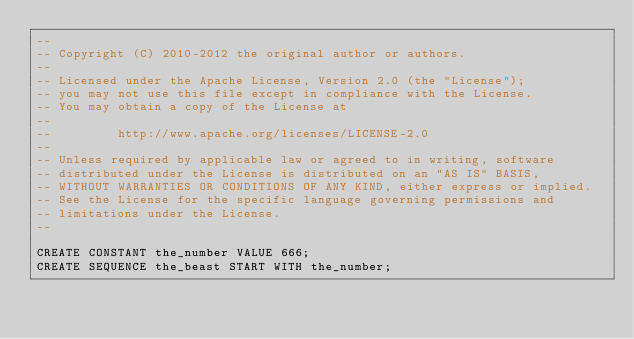<code> <loc_0><loc_0><loc_500><loc_500><_SQL_>--
-- Copyright (C) 2010-2012 the original author or authors.
--
-- Licensed under the Apache License, Version 2.0 (the "License");
-- you may not use this file except in compliance with the License.
-- You may obtain a copy of the License at
--
--         http://www.apache.org/licenses/LICENSE-2.0
--
-- Unless required by applicable law or agreed to in writing, software
-- distributed under the License is distributed on an "AS IS" BASIS,
-- WITHOUT WARRANTIES OR CONDITIONS OF ANY KIND, either express or implied.
-- See the License for the specific language governing permissions and
-- limitations under the License.
--

CREATE CONSTANT the_number VALUE 666;
CREATE SEQUENCE the_beast START WITH the_number;</code> 